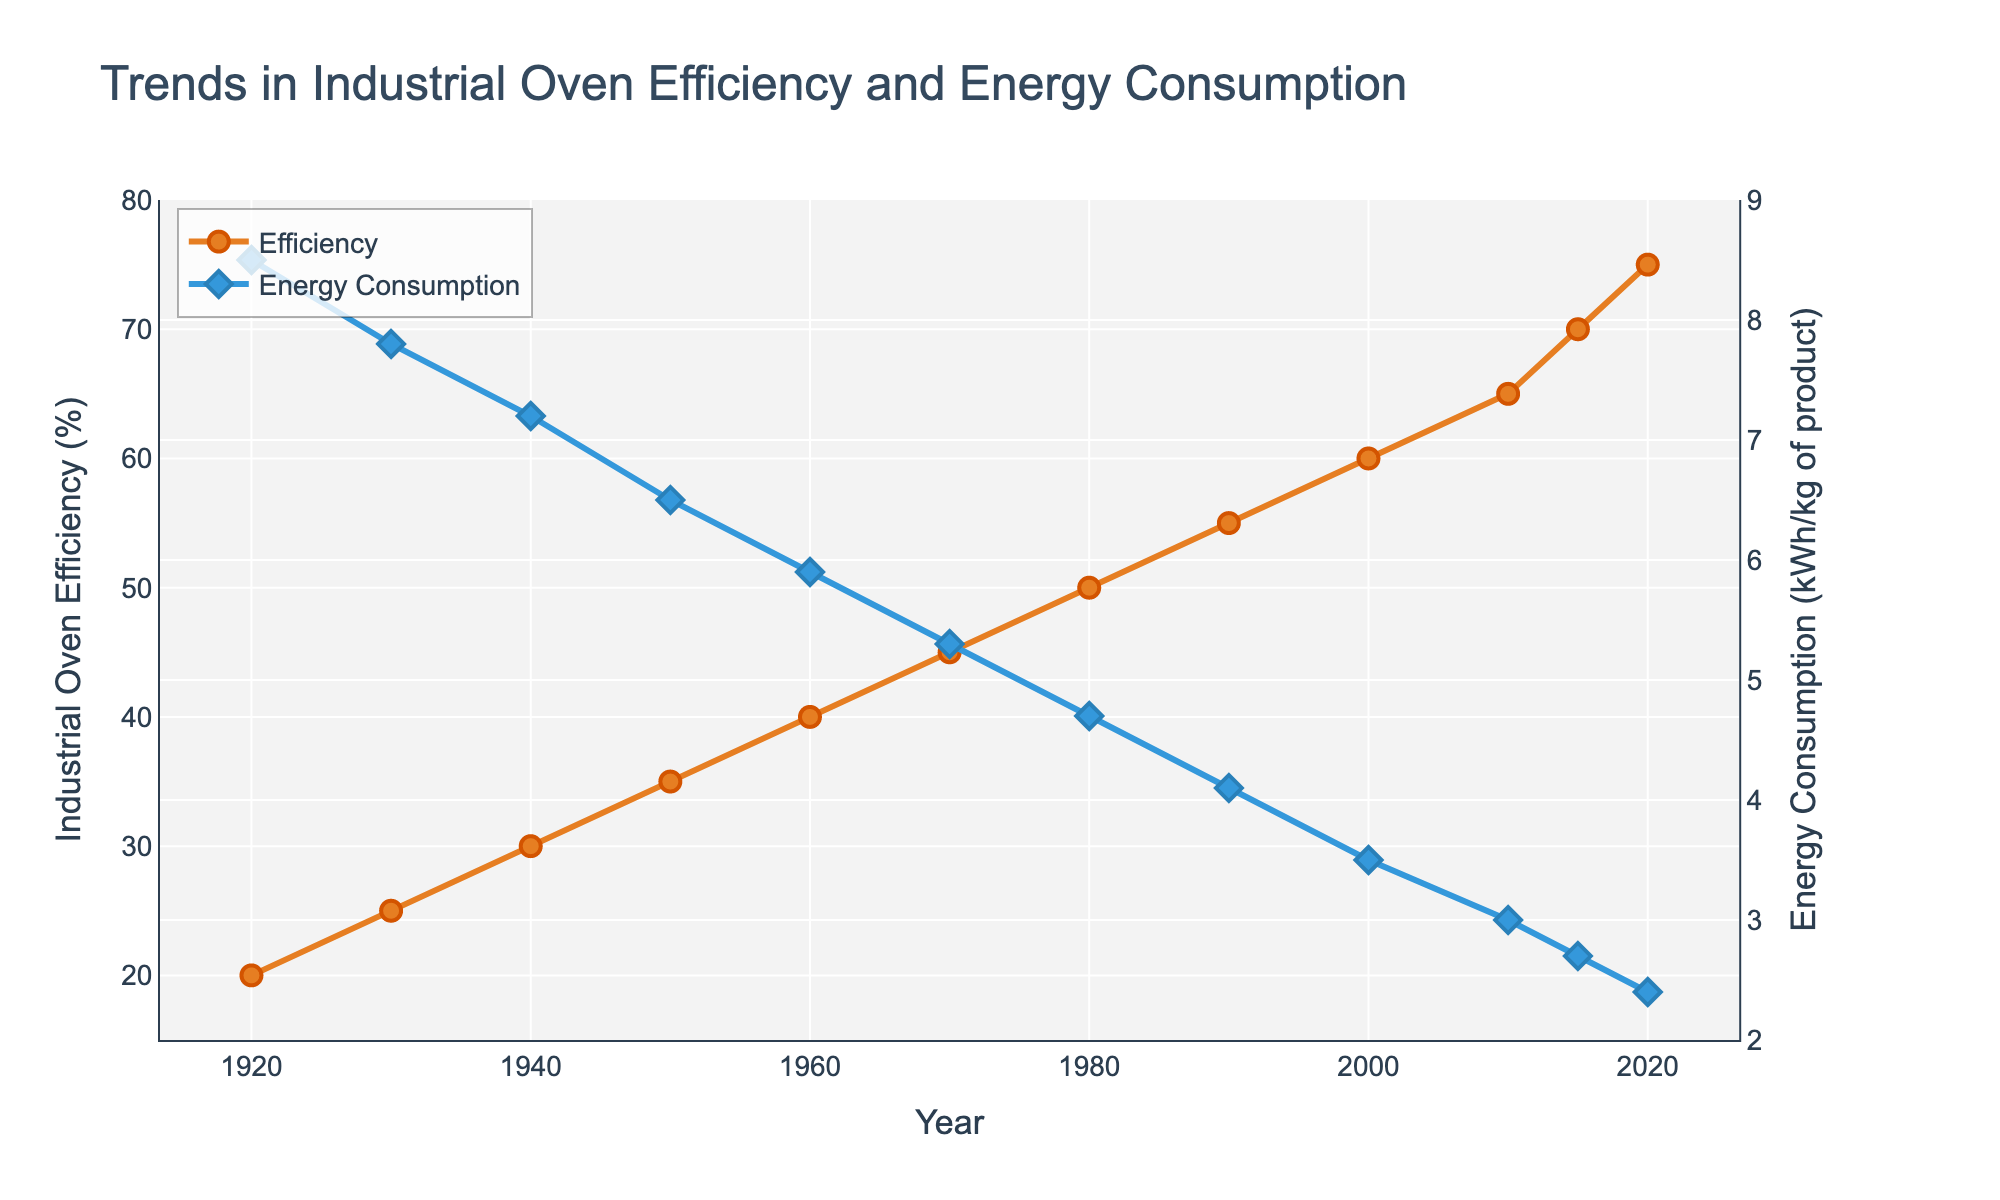What year did industrial oven efficiency reach 50%? The chart plots industrial oven efficiency over time. By locating the point where the efficiency line intersects the 50% mark, we see that it happens in 1980.
Answer: 1980 How has energy consumption changed from 1920 to 2020? In 1920, the energy consumption is 8.5 kWh/kg of product. By 2020, it has decreased to 2.4 kWh/kg of product. Subtracting 2.4 from 8.5 gives the change.
Answer: Decreased by 6.1 kWh/kg Which year saw a higher increase in efficiency: from 1930 to 1940 or from 1940 to 1950? The efficiency increases from 25% to 30% between 1930 and 1940 (an increase of 5%), and from 30% to 35% between 1940 and 1950 (also an increase of 5%). Therefore, the increases are equal.
Answer: Equal What is the trend in energy consumption from 1980 to 2010? Observing the energy consumption plot, we notice a consistent decline from 1980 (4.7 kWh/kg) to 2010 (3.0 kWh/kg). This indicates a downward trend.
Answer: Downward trend How much did industrial oven efficiency improve between 1970 and 2000? In 1970, efficiency is 45%. By 2000, it rises to 60%. The improvement is the difference between these values: 60% - 45% = 15%.
Answer: Improved by 15% What is the approximate energy consumption reduction from 2000 to 2015? Starting at 3.5 kWh/kg in 2000 and going down to 2.7 kWh/kg in 2015, the reduction is 3.5 - 2.7, which equals 0.8 kWh/kg.
Answer: Reduced by 0.8 kWh/kg Is there any period where the efficiency remained constant? By examining the efficiency line, we see it continuously rising without any flat segments, meaning it never remains constant.
Answer: No By how much did energy consumption decrease between 1990 and 2020? Energy consumption reduces from 4.1 kWh/kg in 1990 to 2.4 kWh/kg in 2020. The decrease is calculated as 4.1 - 2.4 = 1.7 kWh/kg.
Answer: Decreased by 1.7 kWh/kg From the visual attributes, what color represents the industrial oven efficiency trend? The efficiency trend line is colored in an orange shade, indicated visually by the color.
Answer: Orange Which year marked the largest single-decade percentage increase in industrial oven efficiency? Reviewing the points, the largest decade increase in efficiency happens between 2010 (65%) and 2015 (70%), a 5 percentage points increase in one decade.
Answer: 2010-2015 